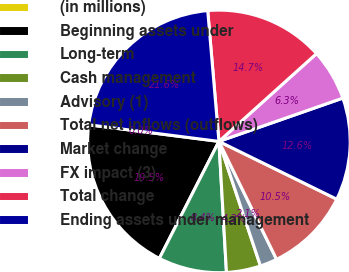<chart> <loc_0><loc_0><loc_500><loc_500><pie_chart><fcel>(in millions)<fcel>Beginning assets under<fcel>Long-term<fcel>Cash management<fcel>Advisory (1)<fcel>Total net inflows (outflows)<fcel>Market change<fcel>FX impact (3)<fcel>Total change<fcel>Ending assets under management<nl><fcel>0.01%<fcel>19.52%<fcel>8.41%<fcel>4.21%<fcel>2.11%<fcel>10.51%<fcel>12.61%<fcel>6.31%<fcel>14.7%<fcel>21.62%<nl></chart> 